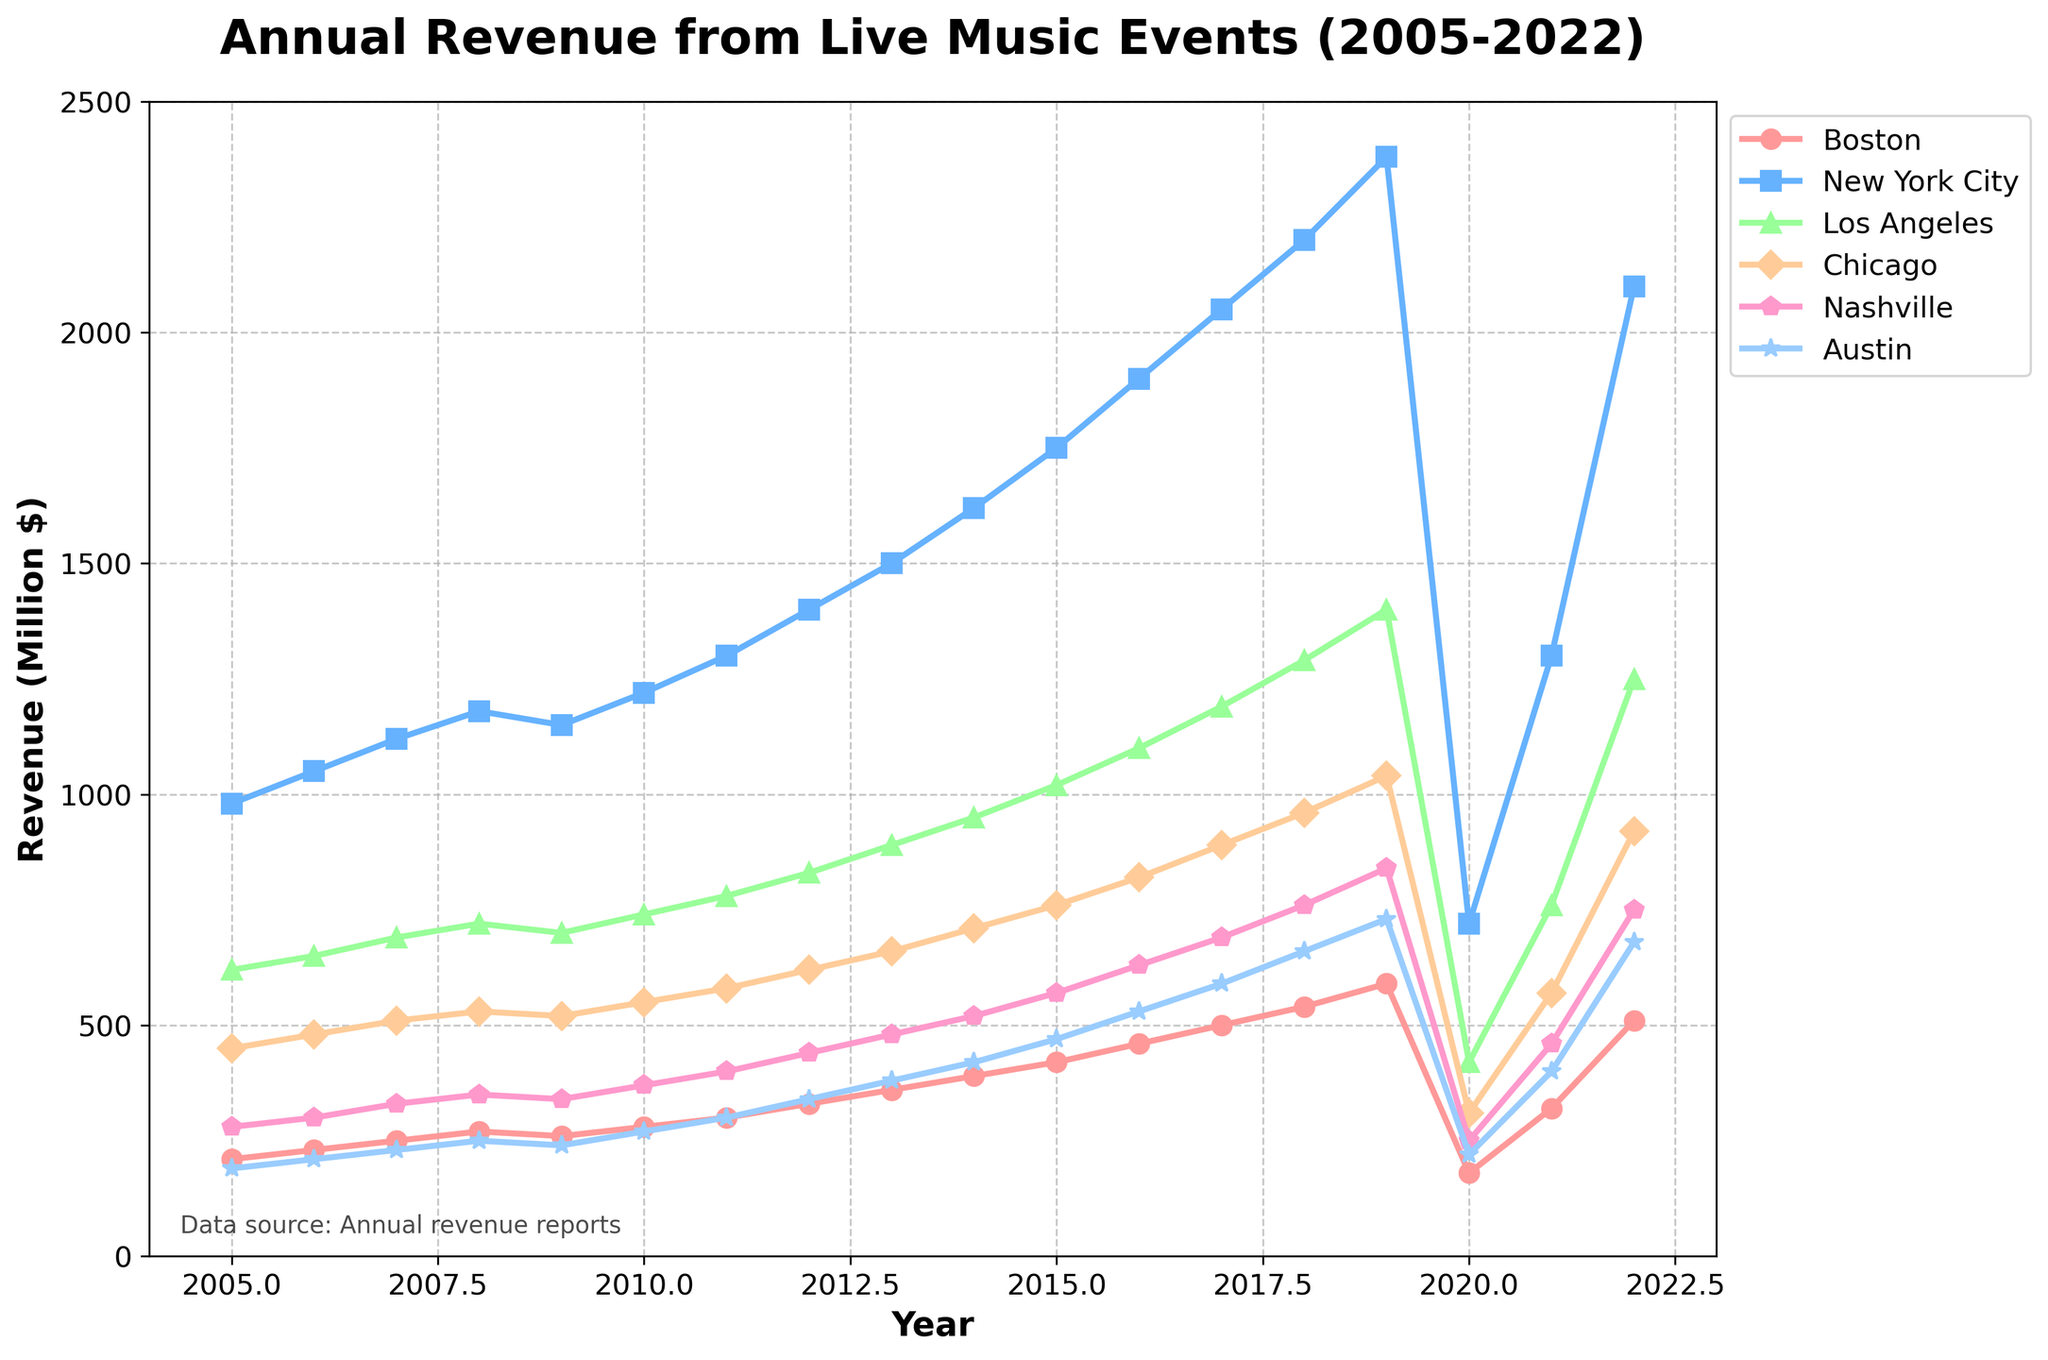Which city had the highest revenue in 2022? By looking at the endpoints of each line for the year 2022, New York City stands out as the one with the highest value.
Answer: New York City How did Boston's revenue in 2020 compare to its revenue in 2021? In 2020, Boston's revenue dropped significantly to 180 million dollars. In 2021, it increased to 320 million dollars. To find the difference: 320 - 180 = 140.
Answer: Increased by 140 million dollars Which city experienced the smallest revenue drop in 2020 compared to 2019? Subtract the 2020 value from the 2019 value for all cities and compare the results. Austin had the smallest drop: 730 - 220 = 510.
Answer: Austin What was the average annual revenue for live music events in Nashville over the first five years (2005-2009)? First, sum the revenues from 2005 to 2009 for Nashville: 280 + 300 + 330 + 350 + 340 = 1600. Then divide by 5: 1600 / 5 = 320 million dollars.
Answer: 320 million dollars Between which consecutive years did Los Angeles see the largest increase in revenue? Check the difference between each consecutive year for Los Angeles. The largest increase occurs between 2007 and 2008: 720 - 690 = 30 million dollars.
Answer: 2007-2008 How does Chicago's revenue growth between 2011 and 2012 compare to Nashville's growth in the same period? Chicago's difference: 620 - 580 = 40 million dollars. Nashville's difference: 440 - 400 = 40 million dollars. Both cities have an equal growth of 40 million dollars between 2011 and 2012.
Answer: Equal, 40 million dollars each What was the total revenue generated by live music events in Boston and Austin in 2017? Sum the 2017 revenues for Boston and Austin: 500 + 590 = 1090 million dollars.
Answer: 1090 million dollars Which city has the steepest overall upward trend from 2005 to 2022? By observing the slope of the lines from 2005 to 2022, New York City's line is the steepest, indicating a strong upward trend.
Answer: New York City 